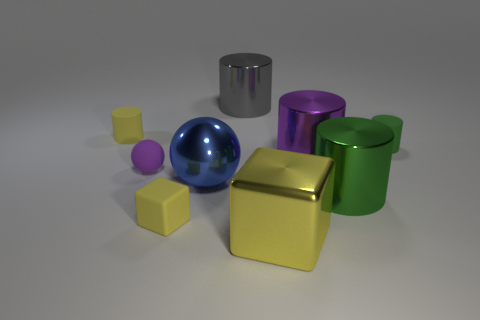Subtract 2 cylinders. How many cylinders are left? 3 Subtract all purple cylinders. How many cylinders are left? 4 Subtract all gray metal cylinders. How many cylinders are left? 4 Subtract all blue cylinders. Subtract all green balls. How many cylinders are left? 5 Subtract all balls. How many objects are left? 7 Add 9 tiny blue things. How many tiny blue things exist? 9 Subtract 1 yellow cylinders. How many objects are left? 8 Subtract all small cylinders. Subtract all purple matte blocks. How many objects are left? 7 Add 4 big gray cylinders. How many big gray cylinders are left? 5 